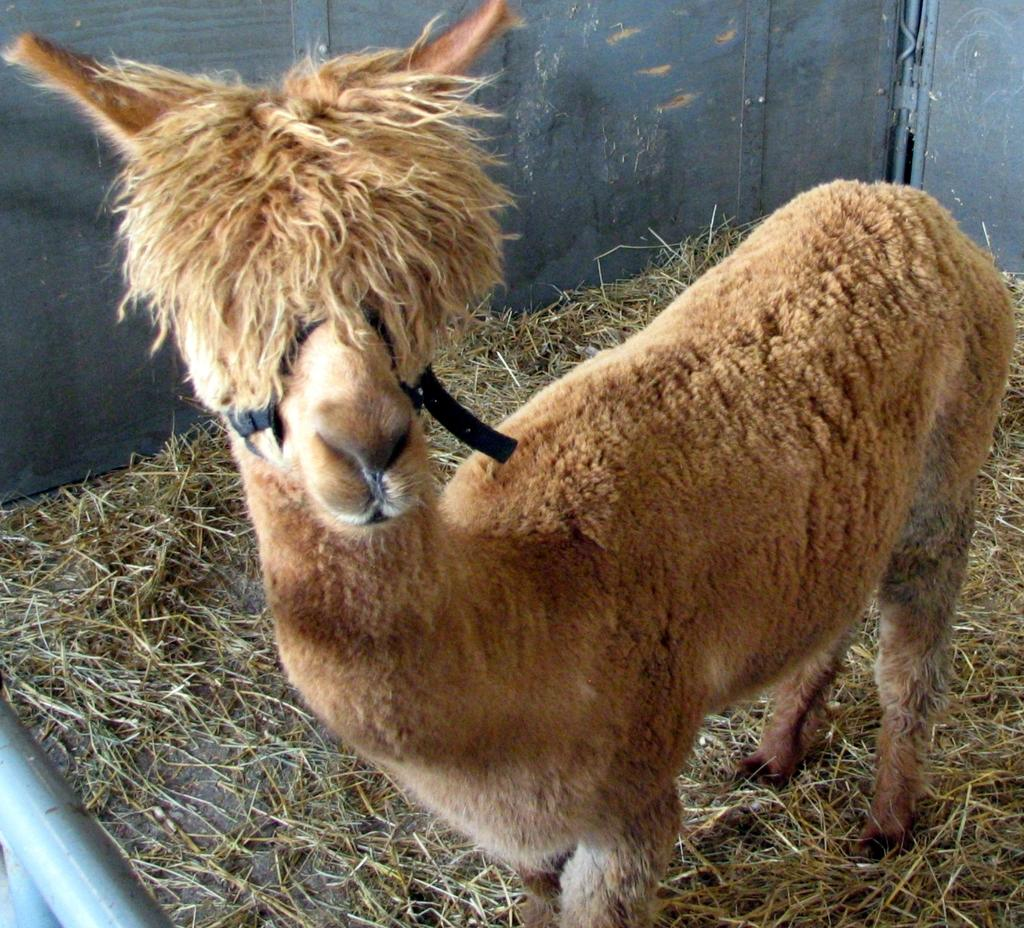What is the main subject in the center of the image? There is an animal in the center of the image. What type of terrain is visible in the image? There is dry grass on the ground in the image. Where is the library located in the image? There is no library present in the image. What type of waterway can be seen in the image? There is no waterway, such as a harbor or channel, present in the image. 